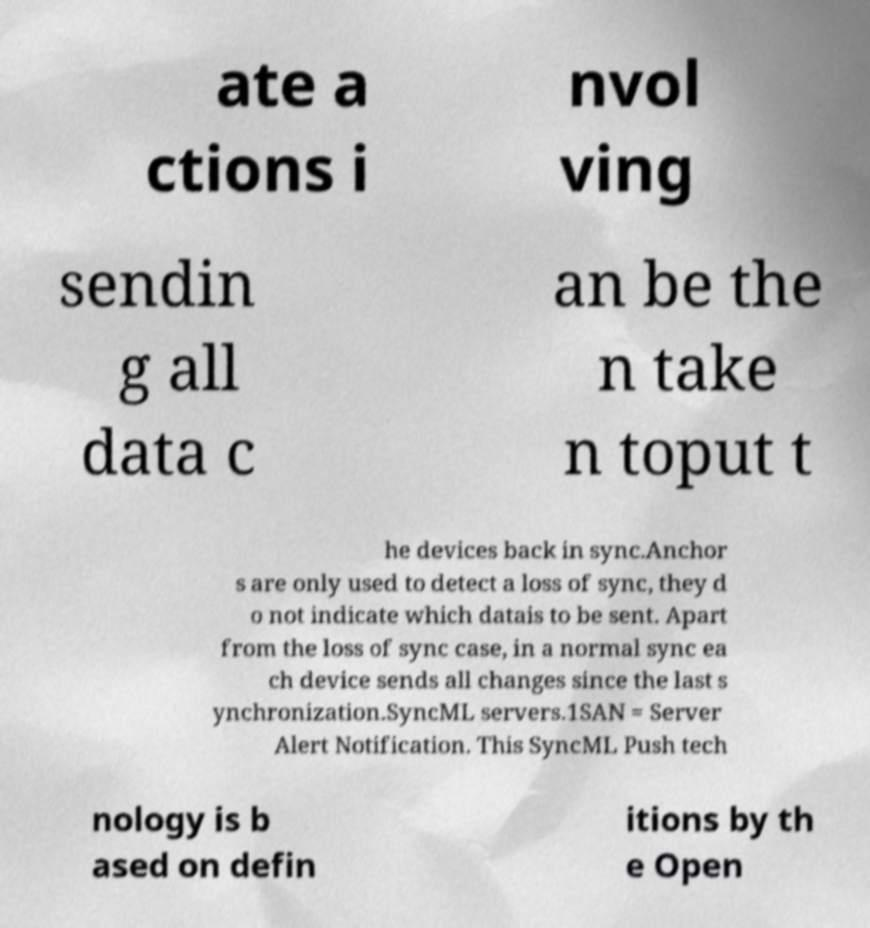Could you assist in decoding the text presented in this image and type it out clearly? ate a ctions i nvol ving sendin g all data c an be the n take n toput t he devices back in sync.Anchor s are only used to detect a loss of sync, they d o not indicate which datais to be sent. Apart from the loss of sync case, in a normal sync ea ch device sends all changes since the last s ynchronization.SyncML servers.1SAN = Server Alert Notification. This SyncML Push tech nology is b ased on defin itions by th e Open 